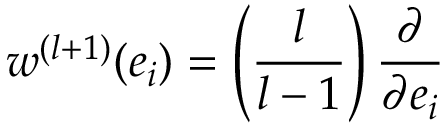Convert formula to latex. <formula><loc_0><loc_0><loc_500><loc_500>w ^ { ( l + 1 ) } ( e _ { i } ) = \left ( \frac { l } { l - 1 } \right ) \frac { \partial } { \partial e _ { i } }</formula> 